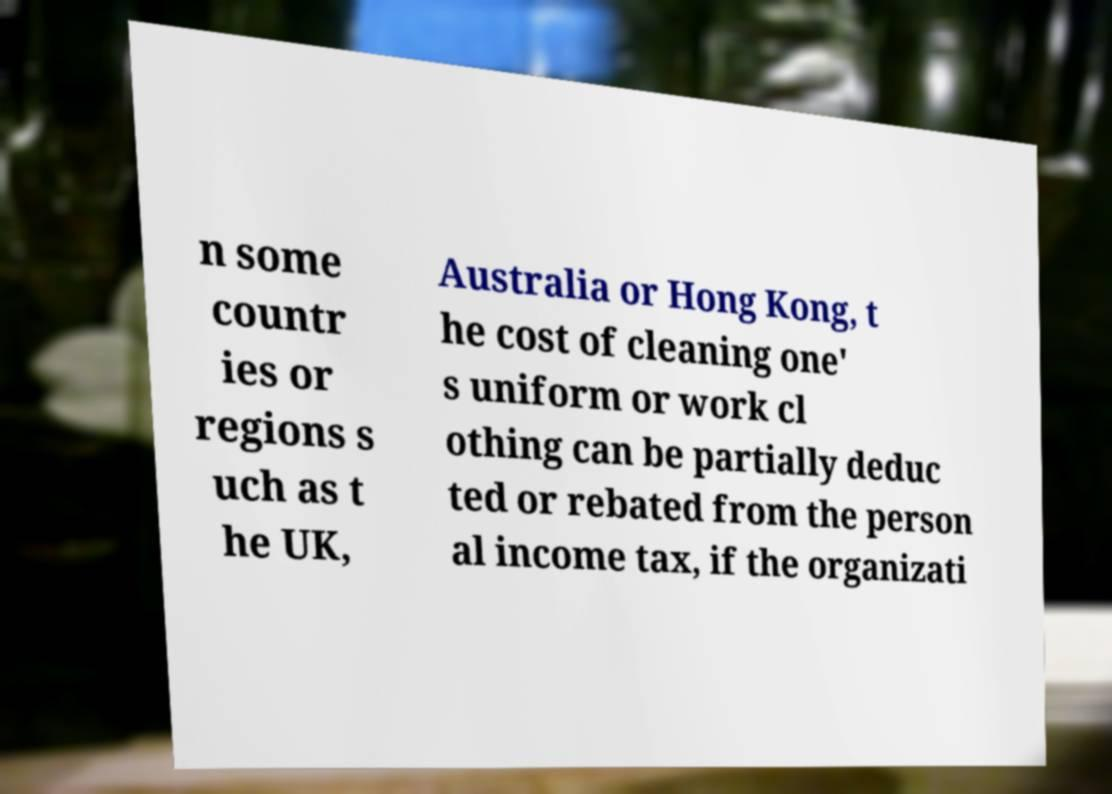Please read and relay the text visible in this image. What does it say? n some countr ies or regions s uch as t he UK, Australia or Hong Kong, t he cost of cleaning one' s uniform or work cl othing can be partially deduc ted or rebated from the person al income tax, if the organizati 